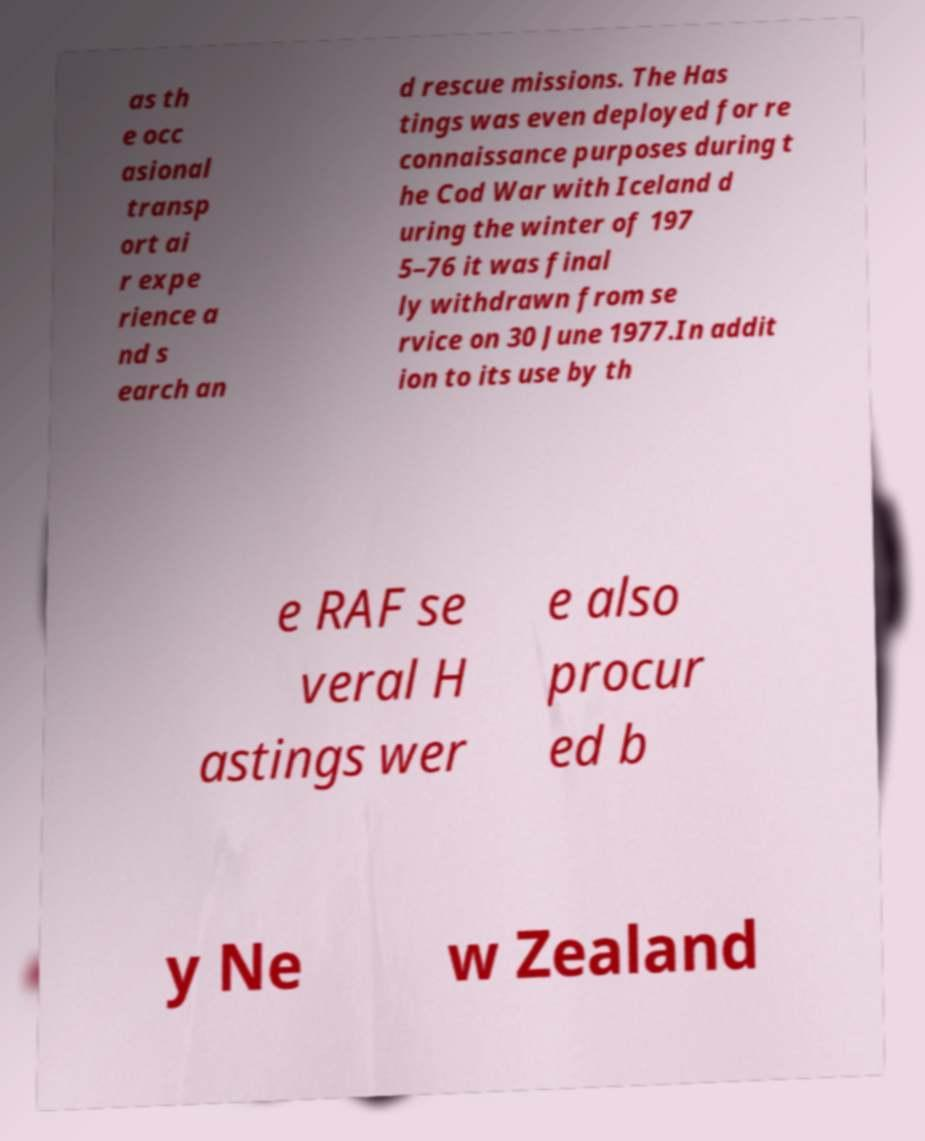I need the written content from this picture converted into text. Can you do that? as th e occ asional transp ort ai r expe rience a nd s earch an d rescue missions. The Has tings was even deployed for re connaissance purposes during t he Cod War with Iceland d uring the winter of 197 5–76 it was final ly withdrawn from se rvice on 30 June 1977.In addit ion to its use by th e RAF se veral H astings wer e also procur ed b y Ne w Zealand 